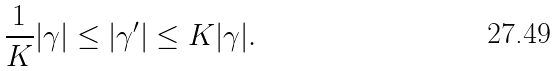Convert formula to latex. <formula><loc_0><loc_0><loc_500><loc_500>\frac { 1 } { K } | \gamma | \leq | \gamma ^ { \prime } | \leq K | \gamma | .</formula> 